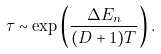Convert formula to latex. <formula><loc_0><loc_0><loc_500><loc_500>\tau \sim \exp \left ( \frac { \Delta E _ { n } } { ( D + 1 ) T } \right ) .</formula> 